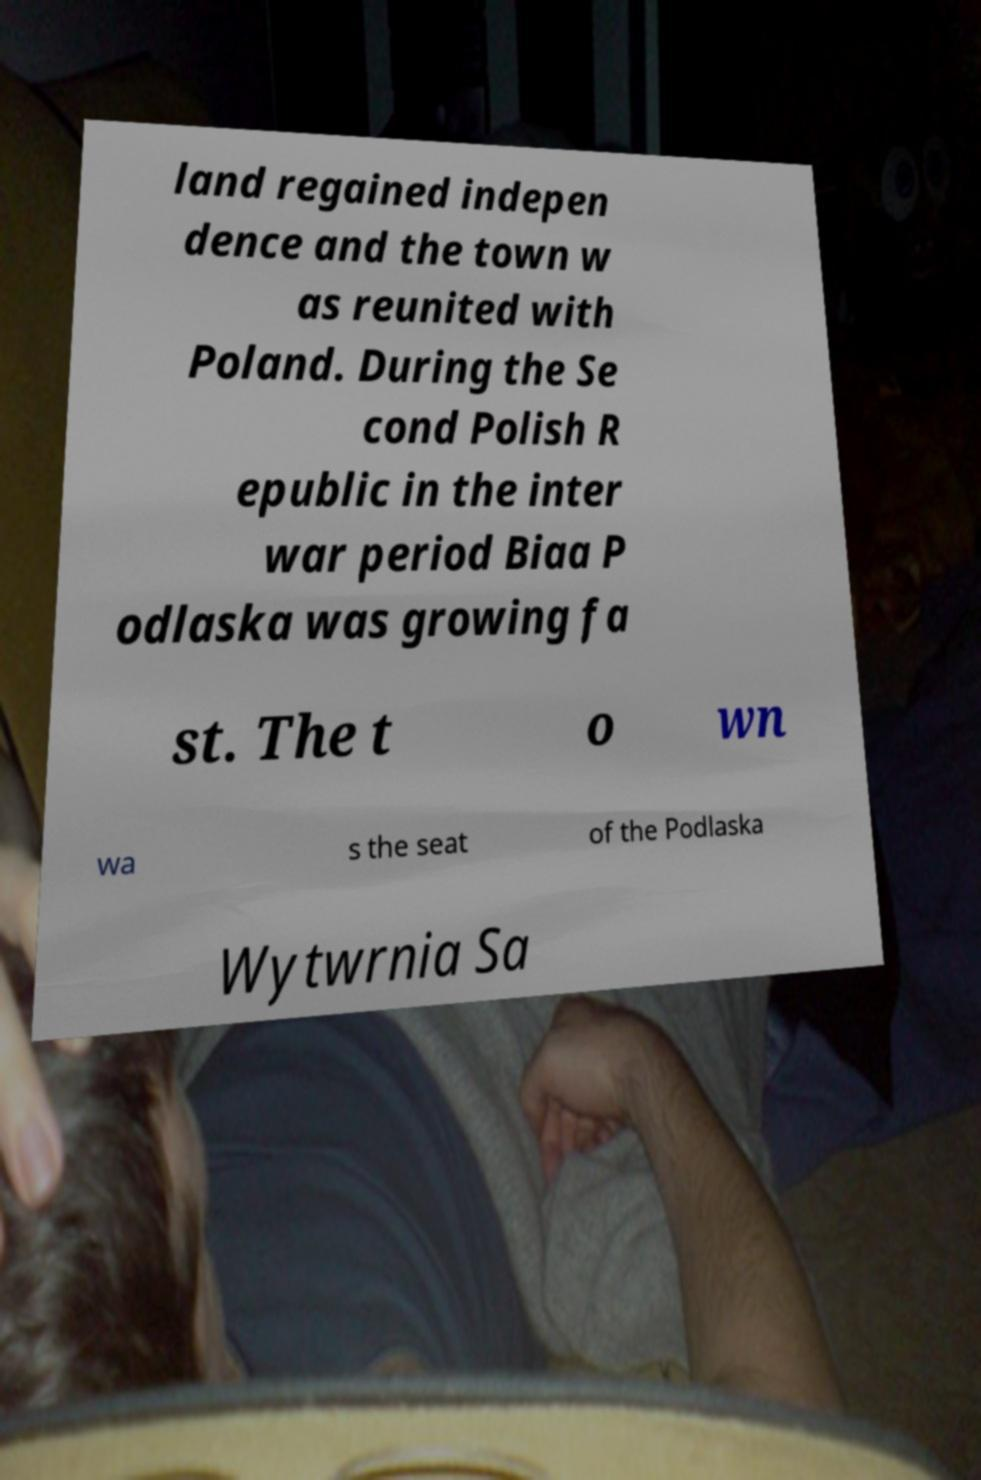Can you accurately transcribe the text from the provided image for me? land regained indepen dence and the town w as reunited with Poland. During the Se cond Polish R epublic in the inter war period Biaa P odlaska was growing fa st. The t o wn wa s the seat of the Podlaska Wytwrnia Sa 